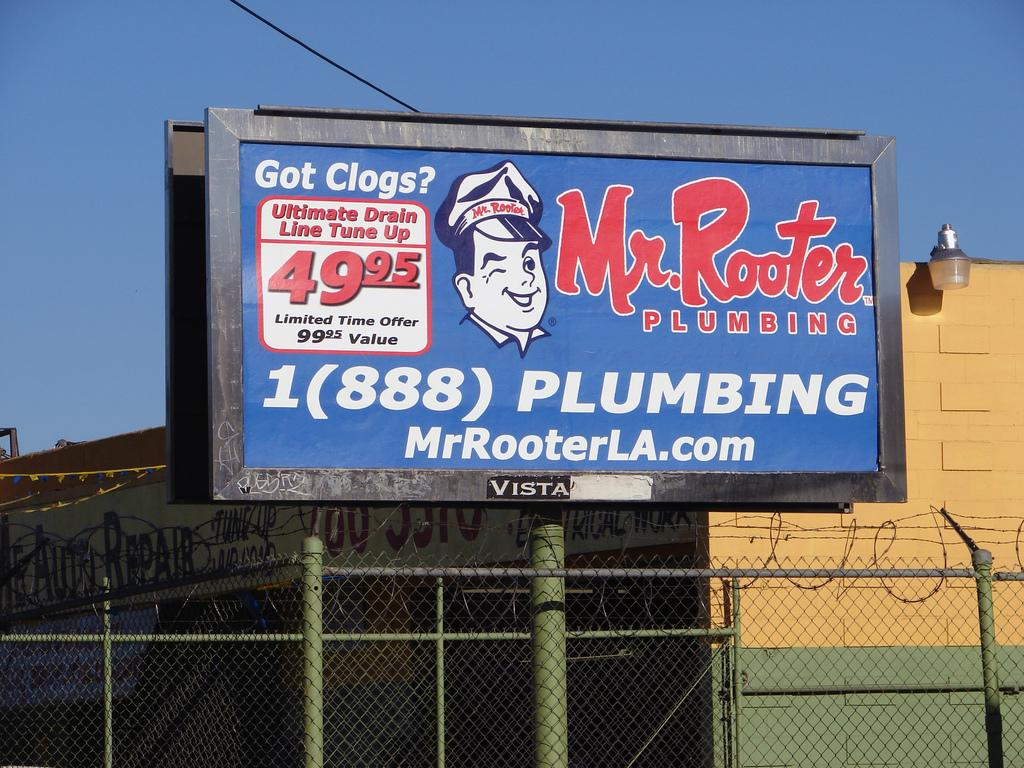<image>
Summarize the visual content of the image. A billboard advertises a drain line tune up by Mr. Rooter Plumbing for under $50. 